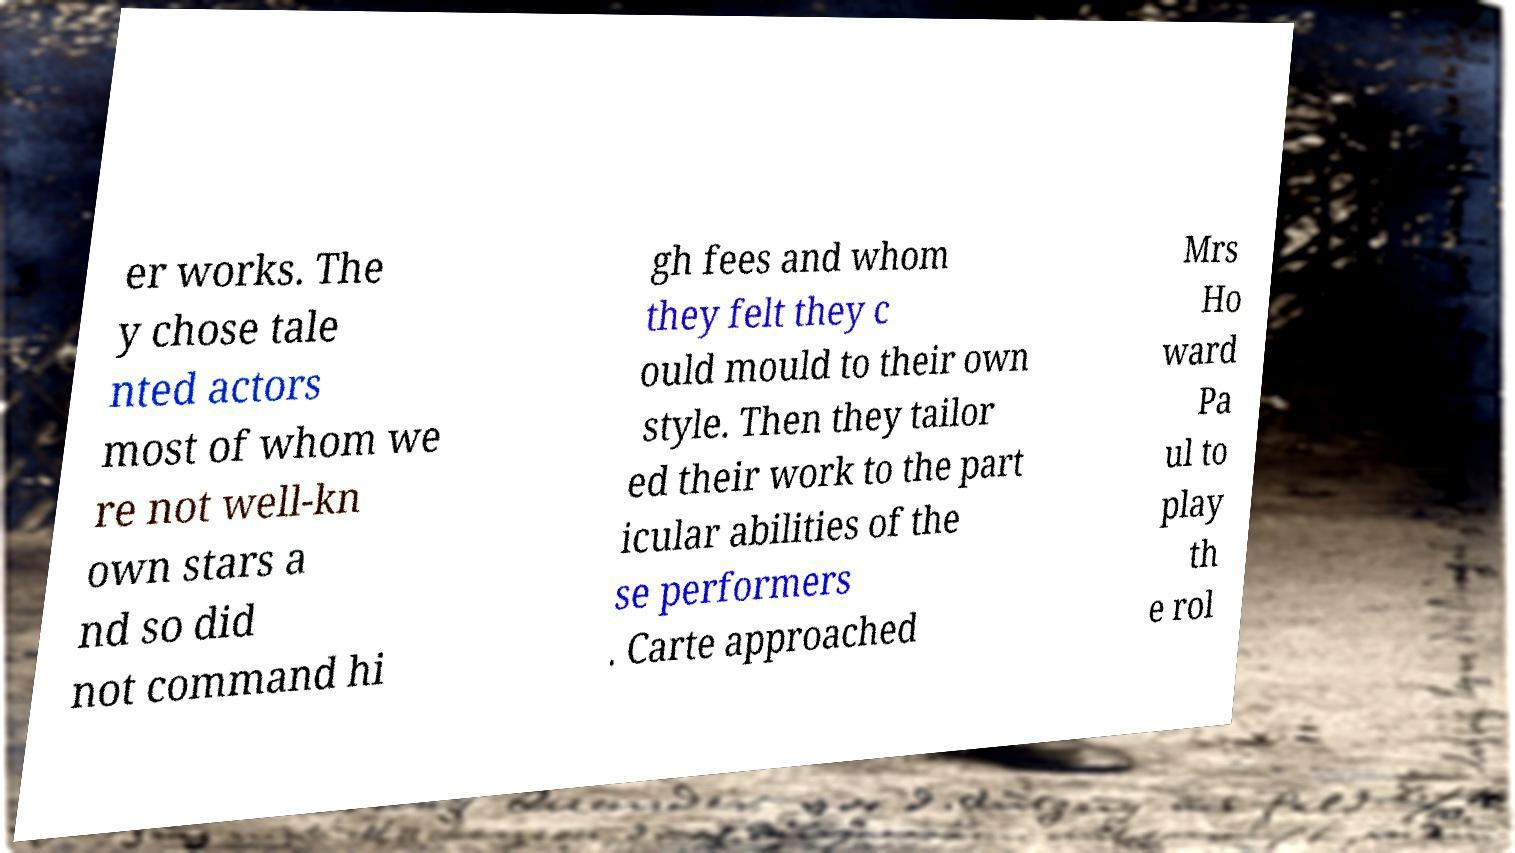Could you assist in decoding the text presented in this image and type it out clearly? er works. The y chose tale nted actors most of whom we re not well-kn own stars a nd so did not command hi gh fees and whom they felt they c ould mould to their own style. Then they tailor ed their work to the part icular abilities of the se performers . Carte approached Mrs Ho ward Pa ul to play th e rol 